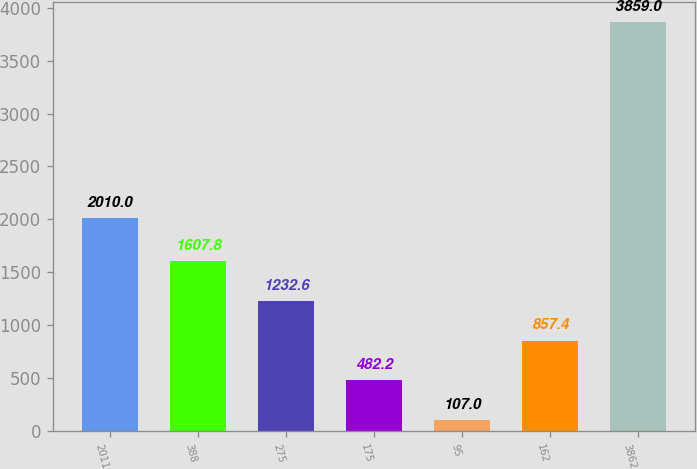Convert chart to OTSL. <chart><loc_0><loc_0><loc_500><loc_500><bar_chart><fcel>2011<fcel>388<fcel>275<fcel>175<fcel>95<fcel>162<fcel>3862<nl><fcel>2010<fcel>1607.8<fcel>1232.6<fcel>482.2<fcel>107<fcel>857.4<fcel>3859<nl></chart> 